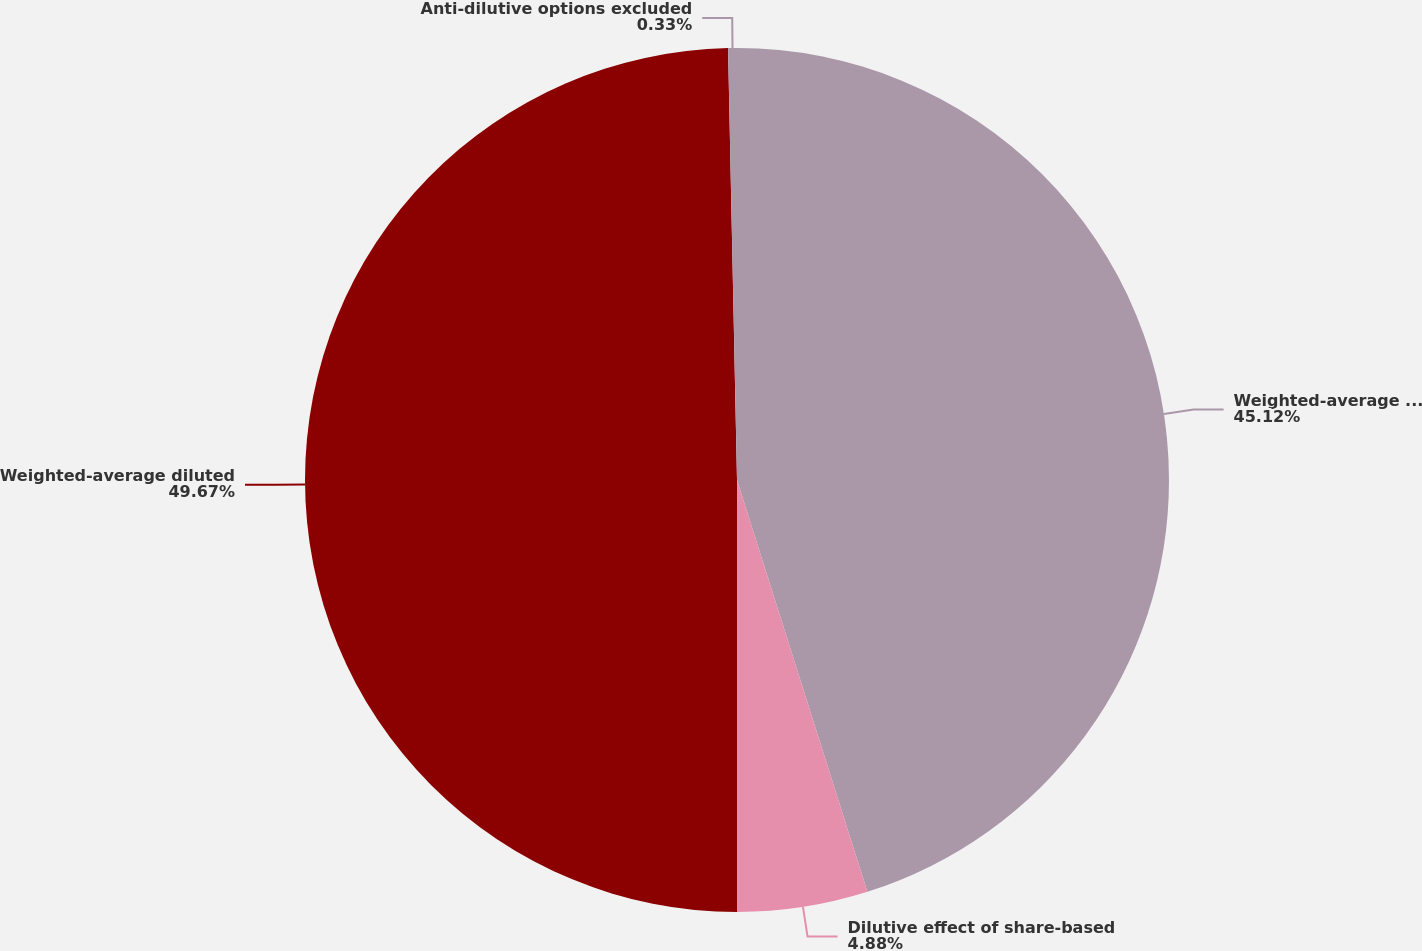Convert chart. <chart><loc_0><loc_0><loc_500><loc_500><pie_chart><fcel>Weighted-average common shares<fcel>Dilutive effect of share-based<fcel>Weighted-average diluted<fcel>Anti-dilutive options excluded<nl><fcel>45.12%<fcel>4.88%<fcel>49.67%<fcel>0.33%<nl></chart> 